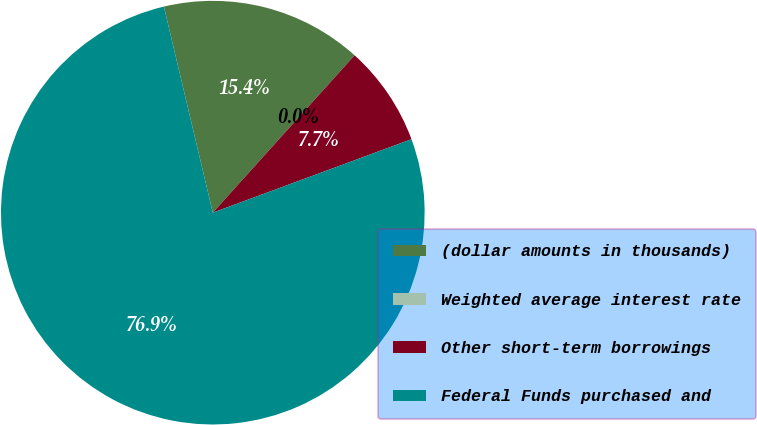Convert chart. <chart><loc_0><loc_0><loc_500><loc_500><pie_chart><fcel>(dollar amounts in thousands)<fcel>Weighted average interest rate<fcel>Other short-term borrowings<fcel>Federal Funds purchased and<nl><fcel>15.38%<fcel>0.0%<fcel>7.69%<fcel>76.92%<nl></chart> 